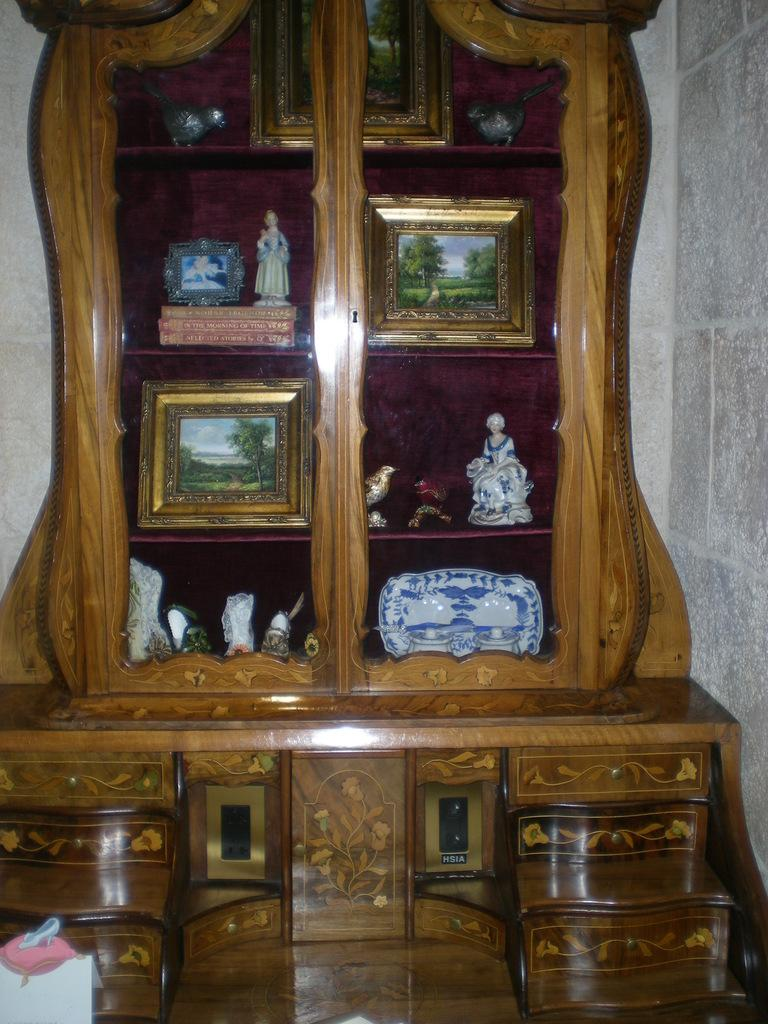What type of furniture is present in the image? There is a cupboard in the image. What can be seen hanging on the walls in the image? There are photo frames in the image. What type of items are present for children to play with? There are toys in the image. What else can be seen in the image besides the mentioned items? There are other objects in the image. What is visible in the background of the image? There is a wall in the background of the image. What type of hobbies can be seen being practiced by the kitten in the image? There is no kitten present in the image, so no hobbies can be observed. What type of grape is being used as a decoration in the image? There is no grape present in the image. 